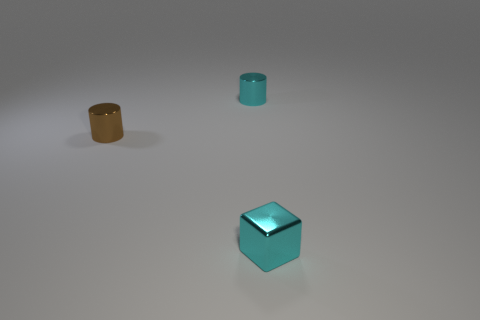What shape is the brown metallic object that is the same size as the metal cube? cylinder 